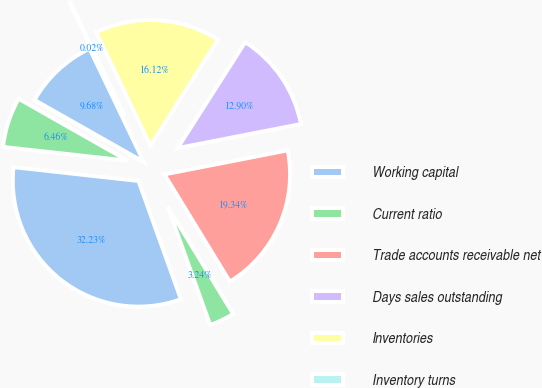Convert chart to OTSL. <chart><loc_0><loc_0><loc_500><loc_500><pie_chart><fcel>Working capital<fcel>Current ratio<fcel>Trade accounts receivable net<fcel>Days sales outstanding<fcel>Inventories<fcel>Inventory turns<fcel>Days payable outstanding (1)<fcel>T otal debt to total capital<nl><fcel>32.23%<fcel>3.24%<fcel>19.34%<fcel>12.9%<fcel>16.12%<fcel>0.02%<fcel>9.68%<fcel>6.46%<nl></chart> 